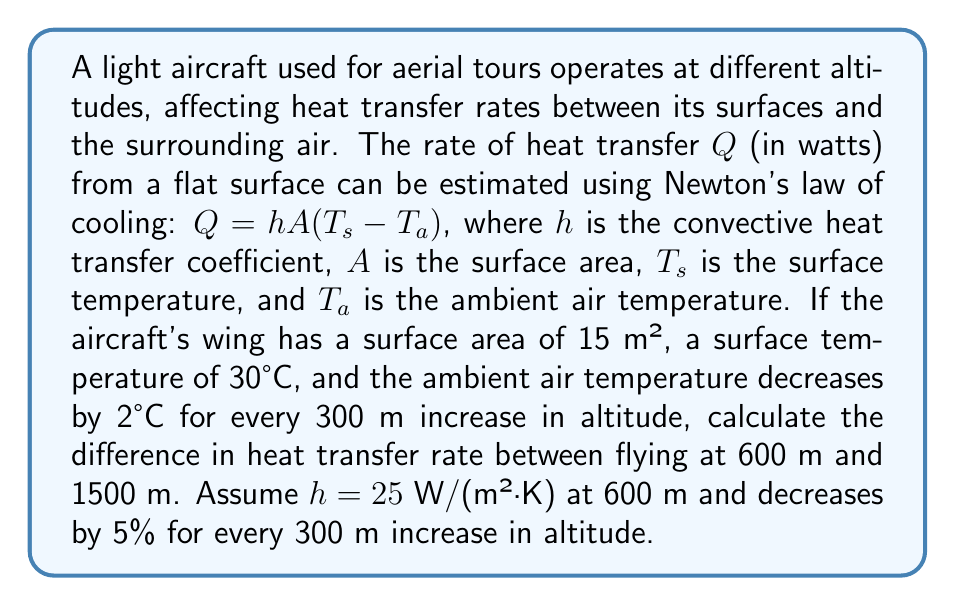Can you answer this question? Let's approach this problem step-by-step:

1) First, we need to calculate the ambient temperatures at both altitudes:
   At 600 m: $T_{a1} = 30°C - (600/300 \times 2°C) = 26°C = 299.15$ K
   At 1500 m: $T_{a2} = 30°C - (1500/300 \times 2°C) = 20°C = 293.15$ K

2) Next, we calculate the convective heat transfer coefficients:
   At 600 m: $h_1 = 25$ W/(m²·K)
   At 1500 m: $h_2 = 25 \times (1 - 0.05)^3 = 21.46875$ W/(m²·K)

3) Now we can calculate the heat transfer rates using $Q = hA(T_s - T_a)$:

   At 600 m:
   $$Q_1 = 25 \times 15 \times (303.15 - 299.15) = 1500$$ W

   At 1500 m:
   $$Q_2 = 21.46875 \times 15 \times (303.15 - 293.15) = 3220.3125$$ W

4) The difference in heat transfer rates is:
   $$\Delta Q = Q_2 - Q_1 = 3220.3125 - 1500 = 1720.3125$$ W
Answer: 1720.3125 W 